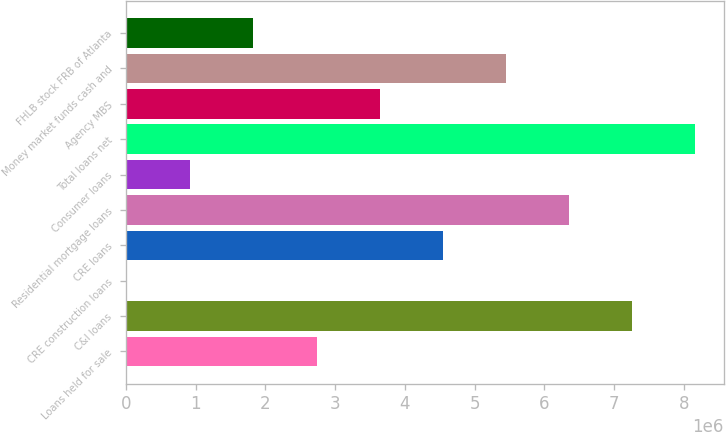<chart> <loc_0><loc_0><loc_500><loc_500><bar_chart><fcel>Loans held for sale<fcel>C&I loans<fcel>CRE construction loans<fcel>CRE loans<fcel>Residential mortgage loans<fcel>Consumer loans<fcel>Total loans net<fcel>Agency MBS<fcel>Money market funds cash and<fcel>FHLB stock FRB of Atlanta<nl><fcel>2.73311e+06<fcel>7.26111e+06<fcel>16314<fcel>4.54431e+06<fcel>6.35551e+06<fcel>921914<fcel>8.16671e+06<fcel>3.63871e+06<fcel>5.44991e+06<fcel>1.82751e+06<nl></chart> 